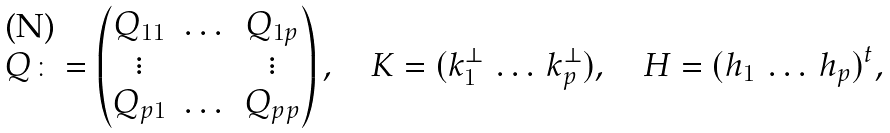<formula> <loc_0><loc_0><loc_500><loc_500>Q \colon = \begin{pmatrix} Q _ { 1 1 } & \dots & Q _ { 1 p } \\ \vdots & & \vdots \\ Q _ { p 1 } & \dots & Q _ { p p } \end{pmatrix} , \quad K = ( k _ { 1 } ^ { \perp } \, \dots \, k _ { p } ^ { \perp } ) , \quad H = ( h _ { 1 } \, \dots \, h _ { p } ) ^ { t } ,</formula> 